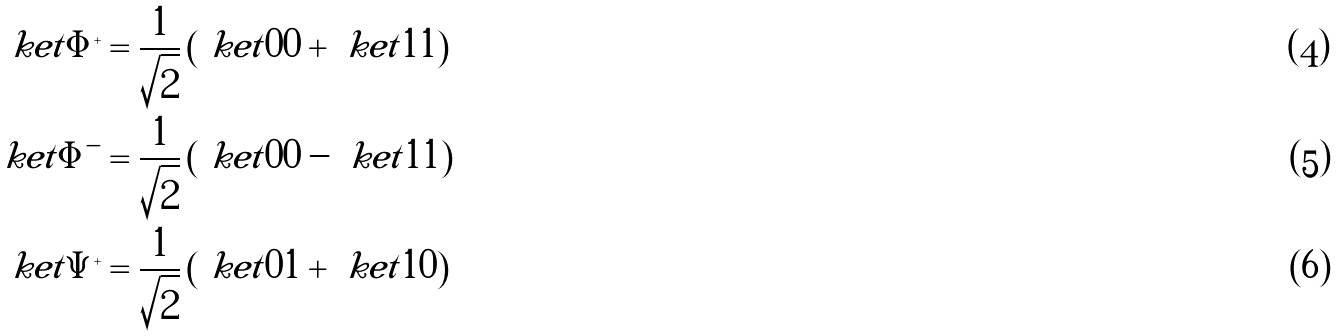Convert formula to latex. <formula><loc_0><loc_0><loc_500><loc_500>\ k e t { \Phi ^ { + } } & = \frac { 1 } { \sqrt { 2 } } \left ( \ k e t { 0 0 } + \ k e t { 1 1 } \right ) \\ \ k e t { \Phi ^ { - } } & = \frac { 1 } { \sqrt { 2 } } \left ( \ k e t { 0 0 } - \ k e t { 1 1 } \right ) \\ \ k e t { \Psi ^ { + } } & = \frac { 1 } { \sqrt { 2 } } \left ( \ k e t { 0 1 } + \ k e t { 1 0 } \right )</formula> 